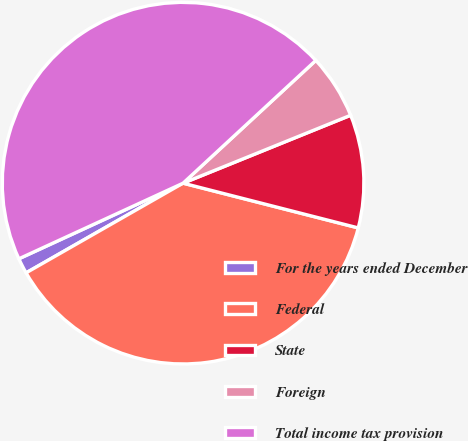Convert chart to OTSL. <chart><loc_0><loc_0><loc_500><loc_500><pie_chart><fcel>For the years ended December<fcel>Federal<fcel>State<fcel>Foreign<fcel>Total income tax provision<nl><fcel>1.39%<fcel>37.76%<fcel>10.11%<fcel>5.75%<fcel>44.99%<nl></chart> 